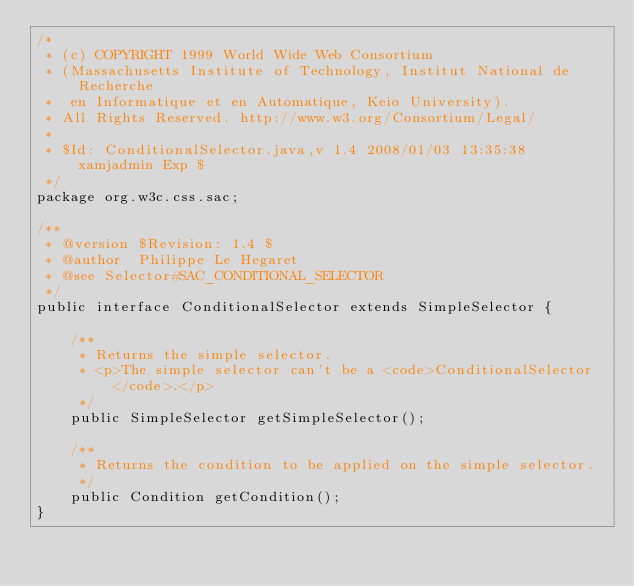<code> <loc_0><loc_0><loc_500><loc_500><_Java_>/*
 * (c) COPYRIGHT 1999 World Wide Web Consortium
 * (Massachusetts Institute of Technology, Institut National de Recherche
 *  en Informatique et en Automatique, Keio University).
 * All Rights Reserved. http://www.w3.org/Consortium/Legal/
 *
 * $Id: ConditionalSelector.java,v 1.4 2008/01/03 13:35:38 xamjadmin Exp $
 */
package org.w3c.css.sac;

/**
 * @version $Revision: 1.4 $
 * @author  Philippe Le Hegaret
 * @see Selector#SAC_CONDITIONAL_SELECTOR
 */
public interface ConditionalSelector extends SimpleSelector {

    /**
     * Returns the simple selector.
     * <p>The simple selector can't be a <code>ConditionalSelector</code>.</p>
     */    
    public SimpleSelector getSimpleSelector();

    /**
     * Returns the condition to be applied on the simple selector.
     */    
    public Condition getCondition();
}
</code> 